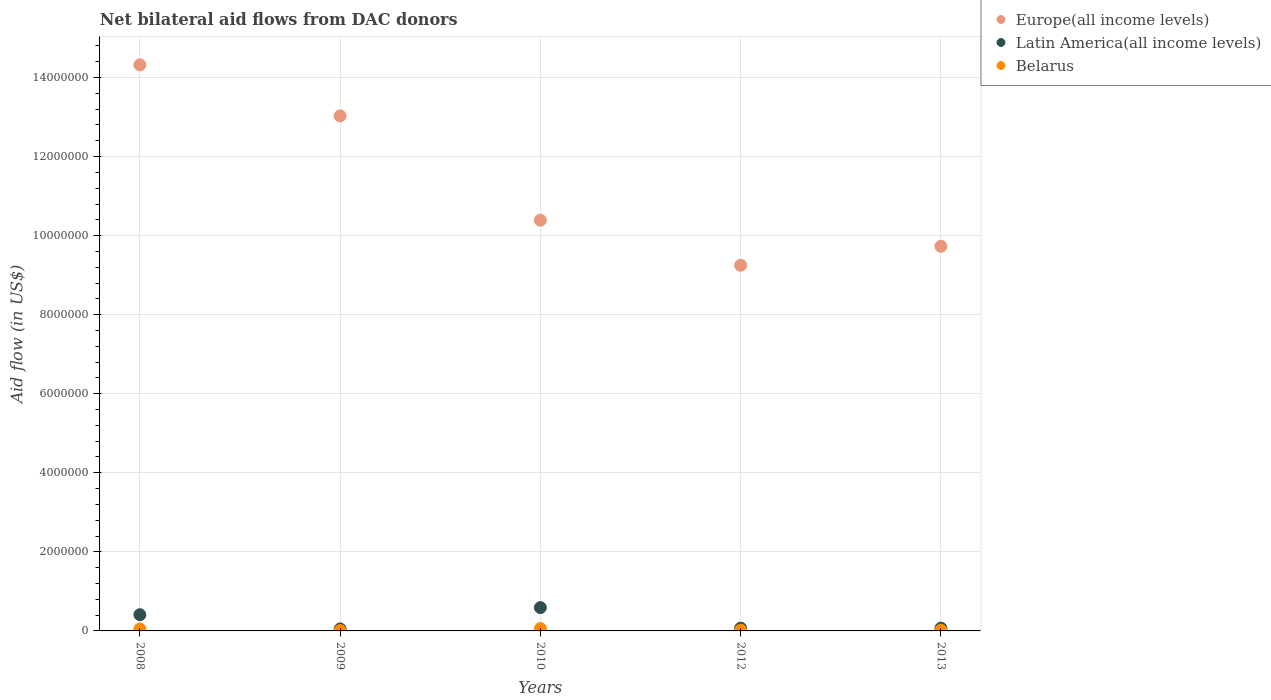How many different coloured dotlines are there?
Provide a succinct answer. 3. What is the net bilateral aid flow in Europe(all income levels) in 2009?
Provide a succinct answer. 1.30e+07. Across all years, what is the maximum net bilateral aid flow in Latin America(all income levels)?
Your answer should be very brief. 5.90e+05. In which year was the net bilateral aid flow in Latin America(all income levels) maximum?
Offer a terse response. 2010. In which year was the net bilateral aid flow in Europe(all income levels) minimum?
Keep it short and to the point. 2012. What is the total net bilateral aid flow in Belarus in the graph?
Keep it short and to the point. 1.60e+05. What is the difference between the net bilateral aid flow in Latin America(all income levels) in 2008 and the net bilateral aid flow in Belarus in 2012?
Keep it short and to the point. 3.90e+05. What is the average net bilateral aid flow in Belarus per year?
Provide a short and direct response. 3.20e+04. In the year 2010, what is the difference between the net bilateral aid flow in Europe(all income levels) and net bilateral aid flow in Belarus?
Provide a succinct answer. 1.03e+07. In how many years, is the net bilateral aid flow in Latin America(all income levels) greater than 5600000 US$?
Offer a terse response. 0. Is the difference between the net bilateral aid flow in Europe(all income levels) in 2009 and 2012 greater than the difference between the net bilateral aid flow in Belarus in 2009 and 2012?
Make the answer very short. Yes. Is the sum of the net bilateral aid flow in Latin America(all income levels) in 2012 and 2013 greater than the maximum net bilateral aid flow in Europe(all income levels) across all years?
Provide a succinct answer. No. Is it the case that in every year, the sum of the net bilateral aid flow in Europe(all income levels) and net bilateral aid flow in Latin America(all income levels)  is greater than the net bilateral aid flow in Belarus?
Your response must be concise. Yes. Is the net bilateral aid flow in Belarus strictly greater than the net bilateral aid flow in Europe(all income levels) over the years?
Your answer should be compact. No. How many dotlines are there?
Make the answer very short. 3. What is the difference between two consecutive major ticks on the Y-axis?
Your response must be concise. 2.00e+06. Are the values on the major ticks of Y-axis written in scientific E-notation?
Ensure brevity in your answer.  No. How are the legend labels stacked?
Make the answer very short. Vertical. What is the title of the graph?
Your answer should be very brief. Net bilateral aid flows from DAC donors. Does "Congo (Democratic)" appear as one of the legend labels in the graph?
Provide a succinct answer. No. What is the label or title of the Y-axis?
Offer a terse response. Aid flow (in US$). What is the Aid flow (in US$) in Europe(all income levels) in 2008?
Keep it short and to the point. 1.43e+07. What is the Aid flow (in US$) of Latin America(all income levels) in 2008?
Ensure brevity in your answer.  4.10e+05. What is the Aid flow (in US$) of Belarus in 2008?
Keep it short and to the point. 5.00e+04. What is the Aid flow (in US$) of Europe(all income levels) in 2009?
Offer a terse response. 1.30e+07. What is the Aid flow (in US$) of Latin America(all income levels) in 2009?
Offer a terse response. 5.00e+04. What is the Aid flow (in US$) in Europe(all income levels) in 2010?
Make the answer very short. 1.04e+07. What is the Aid flow (in US$) of Latin America(all income levels) in 2010?
Your answer should be compact. 5.90e+05. What is the Aid flow (in US$) of Belarus in 2010?
Offer a very short reply. 6.00e+04. What is the Aid flow (in US$) of Europe(all income levels) in 2012?
Make the answer very short. 9.25e+06. What is the Aid flow (in US$) of Belarus in 2012?
Provide a short and direct response. 2.00e+04. What is the Aid flow (in US$) in Europe(all income levels) in 2013?
Make the answer very short. 9.73e+06. Across all years, what is the maximum Aid flow (in US$) in Europe(all income levels)?
Provide a short and direct response. 1.43e+07. Across all years, what is the maximum Aid flow (in US$) in Latin America(all income levels)?
Provide a succinct answer. 5.90e+05. Across all years, what is the minimum Aid flow (in US$) in Europe(all income levels)?
Ensure brevity in your answer.  9.25e+06. Across all years, what is the minimum Aid flow (in US$) in Latin America(all income levels)?
Your response must be concise. 5.00e+04. Across all years, what is the minimum Aid flow (in US$) in Belarus?
Give a very brief answer. 10000. What is the total Aid flow (in US$) of Europe(all income levels) in the graph?
Keep it short and to the point. 5.67e+07. What is the total Aid flow (in US$) of Latin America(all income levels) in the graph?
Provide a succinct answer. 1.19e+06. What is the total Aid flow (in US$) of Belarus in the graph?
Your answer should be very brief. 1.60e+05. What is the difference between the Aid flow (in US$) in Europe(all income levels) in 2008 and that in 2009?
Ensure brevity in your answer.  1.29e+06. What is the difference between the Aid flow (in US$) in Belarus in 2008 and that in 2009?
Ensure brevity in your answer.  4.00e+04. What is the difference between the Aid flow (in US$) in Europe(all income levels) in 2008 and that in 2010?
Your answer should be compact. 3.93e+06. What is the difference between the Aid flow (in US$) of Belarus in 2008 and that in 2010?
Your response must be concise. -10000. What is the difference between the Aid flow (in US$) of Europe(all income levels) in 2008 and that in 2012?
Offer a very short reply. 5.07e+06. What is the difference between the Aid flow (in US$) of Latin America(all income levels) in 2008 and that in 2012?
Make the answer very short. 3.40e+05. What is the difference between the Aid flow (in US$) of Belarus in 2008 and that in 2012?
Make the answer very short. 3.00e+04. What is the difference between the Aid flow (in US$) in Europe(all income levels) in 2008 and that in 2013?
Offer a very short reply. 4.59e+06. What is the difference between the Aid flow (in US$) of Latin America(all income levels) in 2008 and that in 2013?
Ensure brevity in your answer.  3.40e+05. What is the difference between the Aid flow (in US$) of Belarus in 2008 and that in 2013?
Offer a very short reply. 3.00e+04. What is the difference between the Aid flow (in US$) in Europe(all income levels) in 2009 and that in 2010?
Ensure brevity in your answer.  2.64e+06. What is the difference between the Aid flow (in US$) in Latin America(all income levels) in 2009 and that in 2010?
Offer a very short reply. -5.40e+05. What is the difference between the Aid flow (in US$) of Europe(all income levels) in 2009 and that in 2012?
Your response must be concise. 3.78e+06. What is the difference between the Aid flow (in US$) in Europe(all income levels) in 2009 and that in 2013?
Make the answer very short. 3.30e+06. What is the difference between the Aid flow (in US$) in Belarus in 2009 and that in 2013?
Provide a succinct answer. -10000. What is the difference between the Aid flow (in US$) of Europe(all income levels) in 2010 and that in 2012?
Give a very brief answer. 1.14e+06. What is the difference between the Aid flow (in US$) of Latin America(all income levels) in 2010 and that in 2012?
Your answer should be compact. 5.20e+05. What is the difference between the Aid flow (in US$) of Belarus in 2010 and that in 2012?
Your response must be concise. 4.00e+04. What is the difference between the Aid flow (in US$) in Europe(all income levels) in 2010 and that in 2013?
Provide a succinct answer. 6.60e+05. What is the difference between the Aid flow (in US$) in Latin America(all income levels) in 2010 and that in 2013?
Provide a short and direct response. 5.20e+05. What is the difference between the Aid flow (in US$) in Belarus in 2010 and that in 2013?
Make the answer very short. 4.00e+04. What is the difference between the Aid flow (in US$) of Europe(all income levels) in 2012 and that in 2013?
Make the answer very short. -4.80e+05. What is the difference between the Aid flow (in US$) of Latin America(all income levels) in 2012 and that in 2013?
Your response must be concise. 0. What is the difference between the Aid flow (in US$) of Belarus in 2012 and that in 2013?
Provide a succinct answer. 0. What is the difference between the Aid flow (in US$) of Europe(all income levels) in 2008 and the Aid flow (in US$) of Latin America(all income levels) in 2009?
Make the answer very short. 1.43e+07. What is the difference between the Aid flow (in US$) in Europe(all income levels) in 2008 and the Aid flow (in US$) in Belarus in 2009?
Provide a short and direct response. 1.43e+07. What is the difference between the Aid flow (in US$) in Latin America(all income levels) in 2008 and the Aid flow (in US$) in Belarus in 2009?
Offer a terse response. 4.00e+05. What is the difference between the Aid flow (in US$) in Europe(all income levels) in 2008 and the Aid flow (in US$) in Latin America(all income levels) in 2010?
Keep it short and to the point. 1.37e+07. What is the difference between the Aid flow (in US$) of Europe(all income levels) in 2008 and the Aid flow (in US$) of Belarus in 2010?
Your answer should be compact. 1.43e+07. What is the difference between the Aid flow (in US$) in Latin America(all income levels) in 2008 and the Aid flow (in US$) in Belarus in 2010?
Your response must be concise. 3.50e+05. What is the difference between the Aid flow (in US$) in Europe(all income levels) in 2008 and the Aid flow (in US$) in Latin America(all income levels) in 2012?
Keep it short and to the point. 1.42e+07. What is the difference between the Aid flow (in US$) in Europe(all income levels) in 2008 and the Aid flow (in US$) in Belarus in 2012?
Keep it short and to the point. 1.43e+07. What is the difference between the Aid flow (in US$) of Europe(all income levels) in 2008 and the Aid flow (in US$) of Latin America(all income levels) in 2013?
Your answer should be compact. 1.42e+07. What is the difference between the Aid flow (in US$) of Europe(all income levels) in 2008 and the Aid flow (in US$) of Belarus in 2013?
Your answer should be compact. 1.43e+07. What is the difference between the Aid flow (in US$) of Latin America(all income levels) in 2008 and the Aid flow (in US$) of Belarus in 2013?
Your answer should be very brief. 3.90e+05. What is the difference between the Aid flow (in US$) in Europe(all income levels) in 2009 and the Aid flow (in US$) in Latin America(all income levels) in 2010?
Your response must be concise. 1.24e+07. What is the difference between the Aid flow (in US$) of Europe(all income levels) in 2009 and the Aid flow (in US$) of Belarus in 2010?
Make the answer very short. 1.30e+07. What is the difference between the Aid flow (in US$) in Latin America(all income levels) in 2009 and the Aid flow (in US$) in Belarus in 2010?
Your response must be concise. -10000. What is the difference between the Aid flow (in US$) in Europe(all income levels) in 2009 and the Aid flow (in US$) in Latin America(all income levels) in 2012?
Give a very brief answer. 1.30e+07. What is the difference between the Aid flow (in US$) in Europe(all income levels) in 2009 and the Aid flow (in US$) in Belarus in 2012?
Keep it short and to the point. 1.30e+07. What is the difference between the Aid flow (in US$) in Europe(all income levels) in 2009 and the Aid flow (in US$) in Latin America(all income levels) in 2013?
Your answer should be compact. 1.30e+07. What is the difference between the Aid flow (in US$) in Europe(all income levels) in 2009 and the Aid flow (in US$) in Belarus in 2013?
Offer a terse response. 1.30e+07. What is the difference between the Aid flow (in US$) in Latin America(all income levels) in 2009 and the Aid flow (in US$) in Belarus in 2013?
Your response must be concise. 3.00e+04. What is the difference between the Aid flow (in US$) of Europe(all income levels) in 2010 and the Aid flow (in US$) of Latin America(all income levels) in 2012?
Keep it short and to the point. 1.03e+07. What is the difference between the Aid flow (in US$) in Europe(all income levels) in 2010 and the Aid flow (in US$) in Belarus in 2012?
Your response must be concise. 1.04e+07. What is the difference between the Aid flow (in US$) in Latin America(all income levels) in 2010 and the Aid flow (in US$) in Belarus in 2012?
Make the answer very short. 5.70e+05. What is the difference between the Aid flow (in US$) of Europe(all income levels) in 2010 and the Aid flow (in US$) of Latin America(all income levels) in 2013?
Offer a terse response. 1.03e+07. What is the difference between the Aid flow (in US$) of Europe(all income levels) in 2010 and the Aid flow (in US$) of Belarus in 2013?
Make the answer very short. 1.04e+07. What is the difference between the Aid flow (in US$) in Latin America(all income levels) in 2010 and the Aid flow (in US$) in Belarus in 2013?
Keep it short and to the point. 5.70e+05. What is the difference between the Aid flow (in US$) in Europe(all income levels) in 2012 and the Aid flow (in US$) in Latin America(all income levels) in 2013?
Keep it short and to the point. 9.18e+06. What is the difference between the Aid flow (in US$) in Europe(all income levels) in 2012 and the Aid flow (in US$) in Belarus in 2013?
Your answer should be compact. 9.23e+06. What is the average Aid flow (in US$) of Europe(all income levels) per year?
Your answer should be very brief. 1.13e+07. What is the average Aid flow (in US$) of Latin America(all income levels) per year?
Offer a very short reply. 2.38e+05. What is the average Aid flow (in US$) in Belarus per year?
Your answer should be compact. 3.20e+04. In the year 2008, what is the difference between the Aid flow (in US$) of Europe(all income levels) and Aid flow (in US$) of Latin America(all income levels)?
Give a very brief answer. 1.39e+07. In the year 2008, what is the difference between the Aid flow (in US$) of Europe(all income levels) and Aid flow (in US$) of Belarus?
Offer a very short reply. 1.43e+07. In the year 2008, what is the difference between the Aid flow (in US$) of Latin America(all income levels) and Aid flow (in US$) of Belarus?
Provide a succinct answer. 3.60e+05. In the year 2009, what is the difference between the Aid flow (in US$) in Europe(all income levels) and Aid flow (in US$) in Latin America(all income levels)?
Offer a very short reply. 1.30e+07. In the year 2009, what is the difference between the Aid flow (in US$) of Europe(all income levels) and Aid flow (in US$) of Belarus?
Offer a terse response. 1.30e+07. In the year 2009, what is the difference between the Aid flow (in US$) in Latin America(all income levels) and Aid flow (in US$) in Belarus?
Ensure brevity in your answer.  4.00e+04. In the year 2010, what is the difference between the Aid flow (in US$) in Europe(all income levels) and Aid flow (in US$) in Latin America(all income levels)?
Provide a succinct answer. 9.80e+06. In the year 2010, what is the difference between the Aid flow (in US$) of Europe(all income levels) and Aid flow (in US$) of Belarus?
Ensure brevity in your answer.  1.03e+07. In the year 2010, what is the difference between the Aid flow (in US$) in Latin America(all income levels) and Aid flow (in US$) in Belarus?
Make the answer very short. 5.30e+05. In the year 2012, what is the difference between the Aid flow (in US$) of Europe(all income levels) and Aid flow (in US$) of Latin America(all income levels)?
Give a very brief answer. 9.18e+06. In the year 2012, what is the difference between the Aid flow (in US$) in Europe(all income levels) and Aid flow (in US$) in Belarus?
Offer a terse response. 9.23e+06. In the year 2013, what is the difference between the Aid flow (in US$) of Europe(all income levels) and Aid flow (in US$) of Latin America(all income levels)?
Make the answer very short. 9.66e+06. In the year 2013, what is the difference between the Aid flow (in US$) of Europe(all income levels) and Aid flow (in US$) of Belarus?
Give a very brief answer. 9.71e+06. In the year 2013, what is the difference between the Aid flow (in US$) in Latin America(all income levels) and Aid flow (in US$) in Belarus?
Keep it short and to the point. 5.00e+04. What is the ratio of the Aid flow (in US$) of Europe(all income levels) in 2008 to that in 2009?
Offer a very short reply. 1.1. What is the ratio of the Aid flow (in US$) in Latin America(all income levels) in 2008 to that in 2009?
Make the answer very short. 8.2. What is the ratio of the Aid flow (in US$) of Europe(all income levels) in 2008 to that in 2010?
Keep it short and to the point. 1.38. What is the ratio of the Aid flow (in US$) in Latin America(all income levels) in 2008 to that in 2010?
Your answer should be very brief. 0.69. What is the ratio of the Aid flow (in US$) in Belarus in 2008 to that in 2010?
Give a very brief answer. 0.83. What is the ratio of the Aid flow (in US$) in Europe(all income levels) in 2008 to that in 2012?
Keep it short and to the point. 1.55. What is the ratio of the Aid flow (in US$) in Latin America(all income levels) in 2008 to that in 2012?
Your answer should be compact. 5.86. What is the ratio of the Aid flow (in US$) in Europe(all income levels) in 2008 to that in 2013?
Your answer should be compact. 1.47. What is the ratio of the Aid flow (in US$) of Latin America(all income levels) in 2008 to that in 2013?
Your answer should be very brief. 5.86. What is the ratio of the Aid flow (in US$) in Europe(all income levels) in 2009 to that in 2010?
Offer a very short reply. 1.25. What is the ratio of the Aid flow (in US$) in Latin America(all income levels) in 2009 to that in 2010?
Make the answer very short. 0.08. What is the ratio of the Aid flow (in US$) of Belarus in 2009 to that in 2010?
Offer a very short reply. 0.17. What is the ratio of the Aid flow (in US$) in Europe(all income levels) in 2009 to that in 2012?
Offer a terse response. 1.41. What is the ratio of the Aid flow (in US$) of Belarus in 2009 to that in 2012?
Your response must be concise. 0.5. What is the ratio of the Aid flow (in US$) of Europe(all income levels) in 2009 to that in 2013?
Make the answer very short. 1.34. What is the ratio of the Aid flow (in US$) of Latin America(all income levels) in 2009 to that in 2013?
Offer a very short reply. 0.71. What is the ratio of the Aid flow (in US$) of Belarus in 2009 to that in 2013?
Provide a short and direct response. 0.5. What is the ratio of the Aid flow (in US$) in Europe(all income levels) in 2010 to that in 2012?
Give a very brief answer. 1.12. What is the ratio of the Aid flow (in US$) in Latin America(all income levels) in 2010 to that in 2012?
Your answer should be very brief. 8.43. What is the ratio of the Aid flow (in US$) of Europe(all income levels) in 2010 to that in 2013?
Provide a short and direct response. 1.07. What is the ratio of the Aid flow (in US$) in Latin America(all income levels) in 2010 to that in 2013?
Keep it short and to the point. 8.43. What is the ratio of the Aid flow (in US$) of Belarus in 2010 to that in 2013?
Give a very brief answer. 3. What is the ratio of the Aid flow (in US$) in Europe(all income levels) in 2012 to that in 2013?
Make the answer very short. 0.95. What is the ratio of the Aid flow (in US$) of Latin America(all income levels) in 2012 to that in 2013?
Provide a succinct answer. 1. What is the ratio of the Aid flow (in US$) of Belarus in 2012 to that in 2013?
Keep it short and to the point. 1. What is the difference between the highest and the second highest Aid flow (in US$) of Europe(all income levels)?
Ensure brevity in your answer.  1.29e+06. What is the difference between the highest and the second highest Aid flow (in US$) in Latin America(all income levels)?
Ensure brevity in your answer.  1.80e+05. What is the difference between the highest and the second highest Aid flow (in US$) in Belarus?
Ensure brevity in your answer.  10000. What is the difference between the highest and the lowest Aid flow (in US$) in Europe(all income levels)?
Provide a succinct answer. 5.07e+06. What is the difference between the highest and the lowest Aid flow (in US$) in Latin America(all income levels)?
Offer a very short reply. 5.40e+05. 